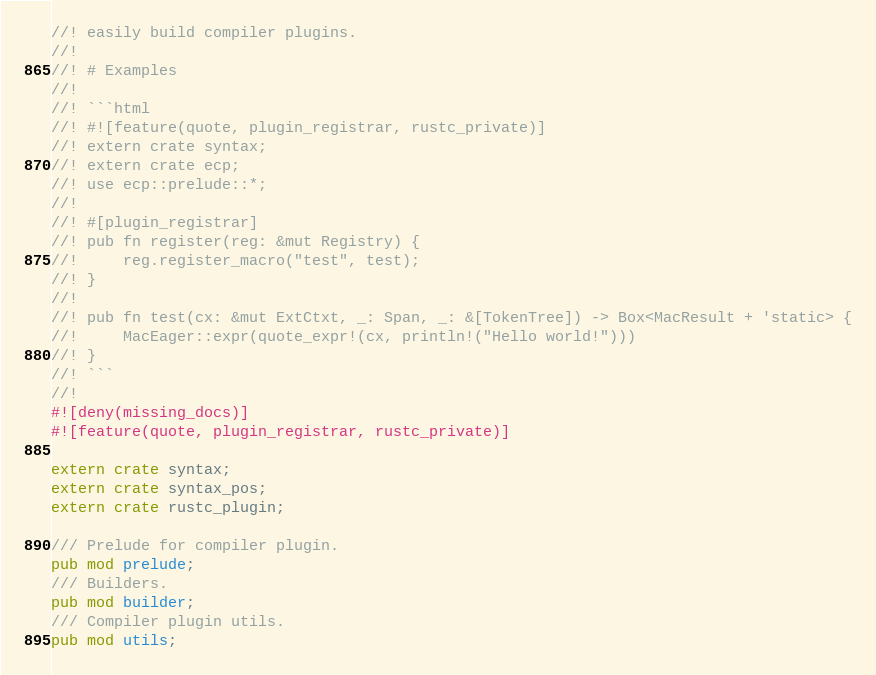<code> <loc_0><loc_0><loc_500><loc_500><_Rust_>//! easily build compiler plugins.
//!
//! # Examples
//!
//! ```html
//! #![feature(quote, plugin_registrar, rustc_private)]
//! extern crate syntax;
//! extern crate ecp;
//! use ecp::prelude::*;
//!
//! #[plugin_registrar]
//! pub fn register(reg: &mut Registry) {
//!     reg.register_macro("test", test);
//! }
//!
//! pub fn test(cx: &mut ExtCtxt, _: Span, _: &[TokenTree]) -> Box<MacResult + 'static> {
//!     MacEager::expr(quote_expr!(cx, println!("Hello world!")))
//! }
//! ```
//!
#![deny(missing_docs)]
#![feature(quote, plugin_registrar, rustc_private)]

extern crate syntax;
extern crate syntax_pos;
extern crate rustc_plugin;

/// Prelude for compiler plugin.
pub mod prelude;
/// Builders.
pub mod builder;
/// Compiler plugin utils.
pub mod utils;
</code> 